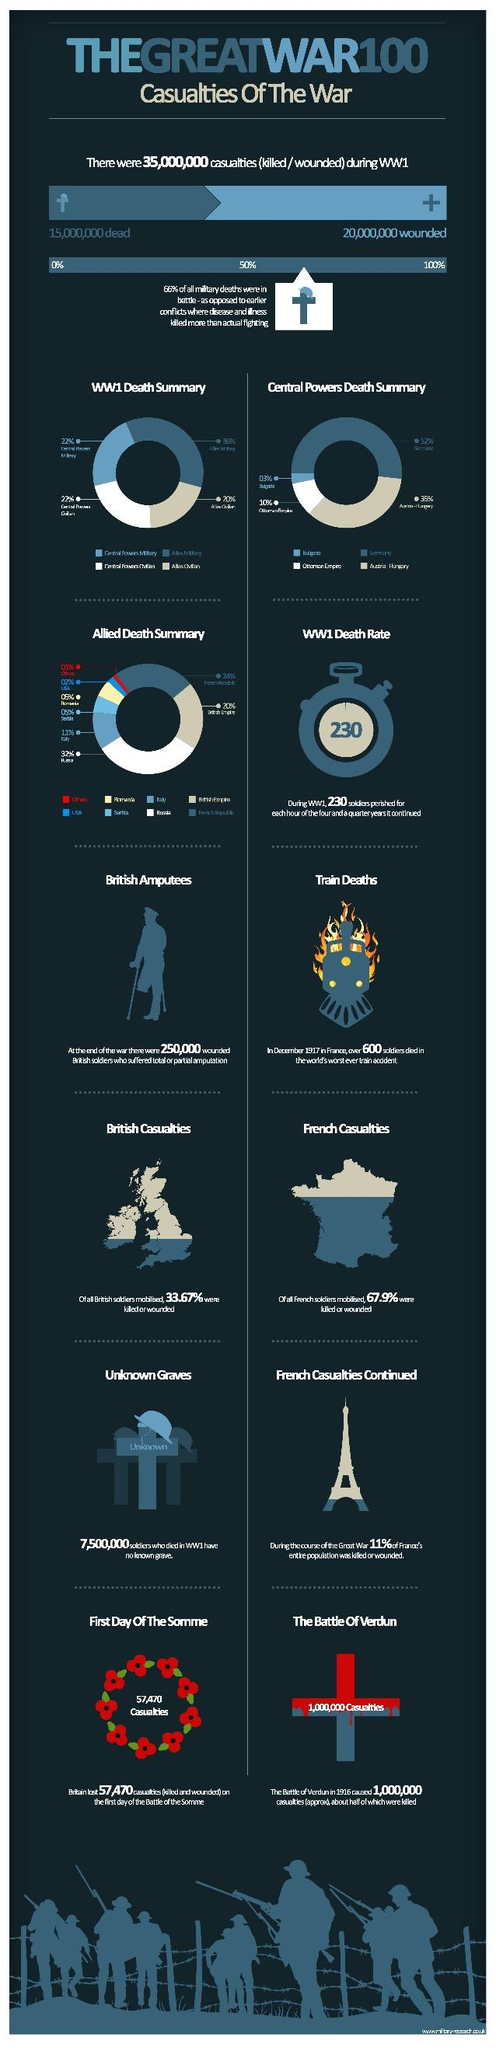Point out several critical features in this image. During the Great War, an estimated 20,000,000 people were injured. According to statistics, during the Great War, a total of 100 soldiers from France were injured or lost their lives. Out of this number, 67.9% were injured or lost their lives. The Great War resulted in the deaths of 15,000,000 people. During the Great War, a significant percentage of people from Britain were injured or lost their lives. Specifically, it is estimated that approximately 66.33% of the population was affected in some way. 